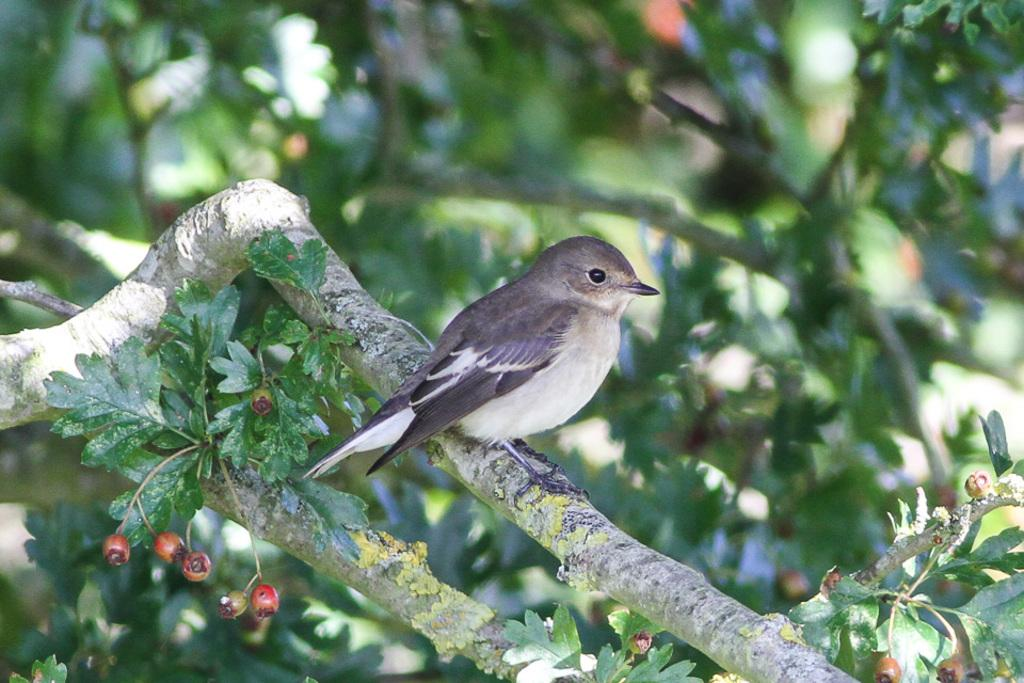What type of animal can be seen in the image? There is a bird in the image. Where is the bird located? The bird is on the branch of a tree. What can be seen in the background of the image? There are trees visible in the background of the image. What type of feast is being prepared in the image? There is no feast being prepared in the image; it features a bird on a tree branch. Can you tell me the make and model of the camera used to capture the image? The information provided does not include details about the camera used to capture the image. 